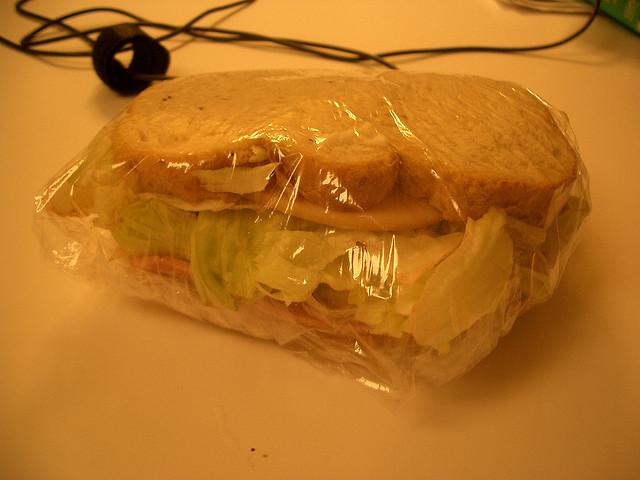IS there lettuce on this sandwich?
Be succinct. Yes. Is this enough for 10 people?
Write a very short answer. No. What is covering the sandwich?
Concise answer only. Plastic. 